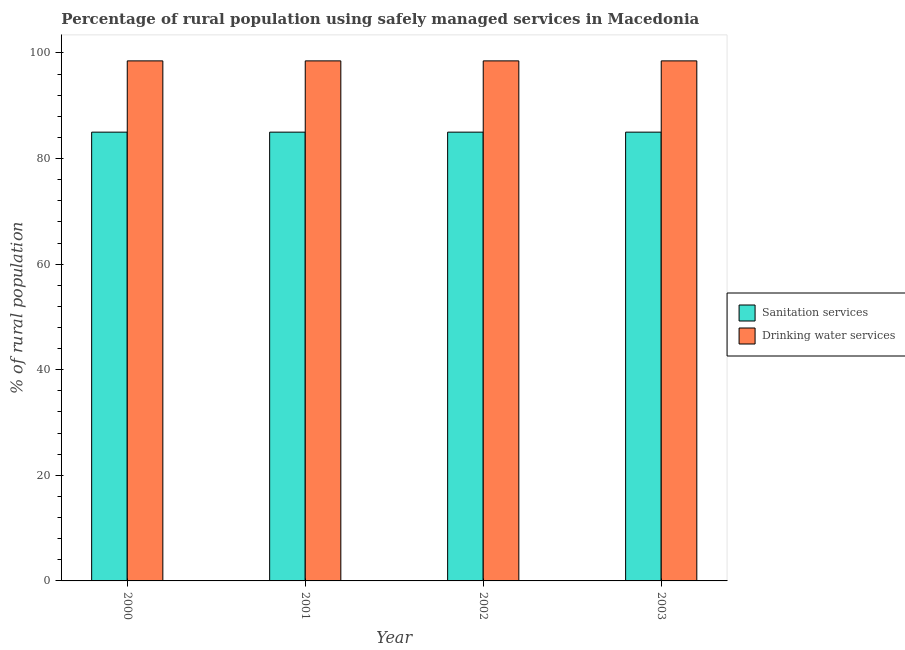How many groups of bars are there?
Keep it short and to the point. 4. Are the number of bars per tick equal to the number of legend labels?
Provide a short and direct response. Yes. Are the number of bars on each tick of the X-axis equal?
Offer a very short reply. Yes. How many bars are there on the 4th tick from the left?
Provide a succinct answer. 2. How many bars are there on the 2nd tick from the right?
Provide a short and direct response. 2. What is the percentage of rural population who used drinking water services in 2003?
Ensure brevity in your answer.  98.5. Across all years, what is the maximum percentage of rural population who used drinking water services?
Your response must be concise. 98.5. In which year was the percentage of rural population who used sanitation services minimum?
Your response must be concise. 2000. What is the total percentage of rural population who used drinking water services in the graph?
Make the answer very short. 394. What is the difference between the percentage of rural population who used sanitation services in 2003 and the percentage of rural population who used drinking water services in 2001?
Ensure brevity in your answer.  0. In the year 2001, what is the difference between the percentage of rural population who used drinking water services and percentage of rural population who used sanitation services?
Make the answer very short. 0. What is the ratio of the percentage of rural population who used drinking water services in 2001 to that in 2002?
Offer a terse response. 1. Is the percentage of rural population who used drinking water services in 2000 less than that in 2001?
Give a very brief answer. No. Is the difference between the percentage of rural population who used drinking water services in 2002 and 2003 greater than the difference between the percentage of rural population who used sanitation services in 2002 and 2003?
Provide a succinct answer. No. What does the 1st bar from the left in 2002 represents?
Provide a succinct answer. Sanitation services. What does the 1st bar from the right in 2003 represents?
Give a very brief answer. Drinking water services. Are all the bars in the graph horizontal?
Keep it short and to the point. No. Are the values on the major ticks of Y-axis written in scientific E-notation?
Your response must be concise. No. Does the graph contain any zero values?
Make the answer very short. No. How many legend labels are there?
Your answer should be compact. 2. How are the legend labels stacked?
Your response must be concise. Vertical. What is the title of the graph?
Offer a very short reply. Percentage of rural population using safely managed services in Macedonia. Does "Male labourers" appear as one of the legend labels in the graph?
Ensure brevity in your answer.  No. What is the label or title of the X-axis?
Provide a short and direct response. Year. What is the label or title of the Y-axis?
Your response must be concise. % of rural population. What is the % of rural population in Drinking water services in 2000?
Offer a terse response. 98.5. What is the % of rural population of Drinking water services in 2001?
Your answer should be very brief. 98.5. What is the % of rural population of Sanitation services in 2002?
Offer a terse response. 85. What is the % of rural population in Drinking water services in 2002?
Give a very brief answer. 98.5. What is the % of rural population in Drinking water services in 2003?
Offer a terse response. 98.5. Across all years, what is the maximum % of rural population in Sanitation services?
Offer a terse response. 85. Across all years, what is the maximum % of rural population in Drinking water services?
Your response must be concise. 98.5. Across all years, what is the minimum % of rural population of Sanitation services?
Your response must be concise. 85. Across all years, what is the minimum % of rural population of Drinking water services?
Offer a very short reply. 98.5. What is the total % of rural population of Sanitation services in the graph?
Keep it short and to the point. 340. What is the total % of rural population in Drinking water services in the graph?
Offer a very short reply. 394. What is the difference between the % of rural population of Sanitation services in 2000 and that in 2001?
Ensure brevity in your answer.  0. What is the difference between the % of rural population in Drinking water services in 2000 and that in 2001?
Ensure brevity in your answer.  0. What is the difference between the % of rural population in Sanitation services in 2000 and that in 2002?
Give a very brief answer. 0. What is the difference between the % of rural population in Drinking water services in 2000 and that in 2002?
Offer a very short reply. 0. What is the difference between the % of rural population in Sanitation services in 2000 and that in 2003?
Give a very brief answer. 0. What is the difference between the % of rural population in Drinking water services in 2000 and that in 2003?
Ensure brevity in your answer.  0. What is the difference between the % of rural population in Drinking water services in 2001 and that in 2002?
Make the answer very short. 0. What is the difference between the % of rural population in Sanitation services in 2001 and that in 2003?
Provide a short and direct response. 0. What is the difference between the % of rural population in Drinking water services in 2001 and that in 2003?
Offer a very short reply. 0. What is the difference between the % of rural population in Sanitation services in 2002 and that in 2003?
Your answer should be very brief. 0. What is the difference between the % of rural population in Sanitation services in 2000 and the % of rural population in Drinking water services in 2001?
Your answer should be very brief. -13.5. What is the difference between the % of rural population of Sanitation services in 2000 and the % of rural population of Drinking water services in 2002?
Ensure brevity in your answer.  -13.5. What is the difference between the % of rural population in Sanitation services in 2000 and the % of rural population in Drinking water services in 2003?
Ensure brevity in your answer.  -13.5. What is the difference between the % of rural population in Sanitation services in 2001 and the % of rural population in Drinking water services in 2002?
Provide a short and direct response. -13.5. What is the difference between the % of rural population in Sanitation services in 2001 and the % of rural population in Drinking water services in 2003?
Offer a very short reply. -13.5. What is the average % of rural population of Sanitation services per year?
Your response must be concise. 85. What is the average % of rural population in Drinking water services per year?
Keep it short and to the point. 98.5. In the year 2001, what is the difference between the % of rural population in Sanitation services and % of rural population in Drinking water services?
Provide a short and direct response. -13.5. In the year 2002, what is the difference between the % of rural population in Sanitation services and % of rural population in Drinking water services?
Provide a short and direct response. -13.5. What is the ratio of the % of rural population in Sanitation services in 2000 to that in 2001?
Offer a terse response. 1. What is the ratio of the % of rural population of Sanitation services in 2000 to that in 2003?
Provide a succinct answer. 1. What is the ratio of the % of rural population of Drinking water services in 2000 to that in 2003?
Provide a short and direct response. 1. What is the ratio of the % of rural population in Sanitation services in 2001 to that in 2002?
Ensure brevity in your answer.  1. What is the ratio of the % of rural population of Drinking water services in 2001 to that in 2002?
Make the answer very short. 1. What is the ratio of the % of rural population of Sanitation services in 2001 to that in 2003?
Your answer should be compact. 1. What is the ratio of the % of rural population in Drinking water services in 2002 to that in 2003?
Make the answer very short. 1. What is the difference between the highest and the second highest % of rural population of Sanitation services?
Your answer should be very brief. 0. What is the difference between the highest and the lowest % of rural population of Sanitation services?
Ensure brevity in your answer.  0. 